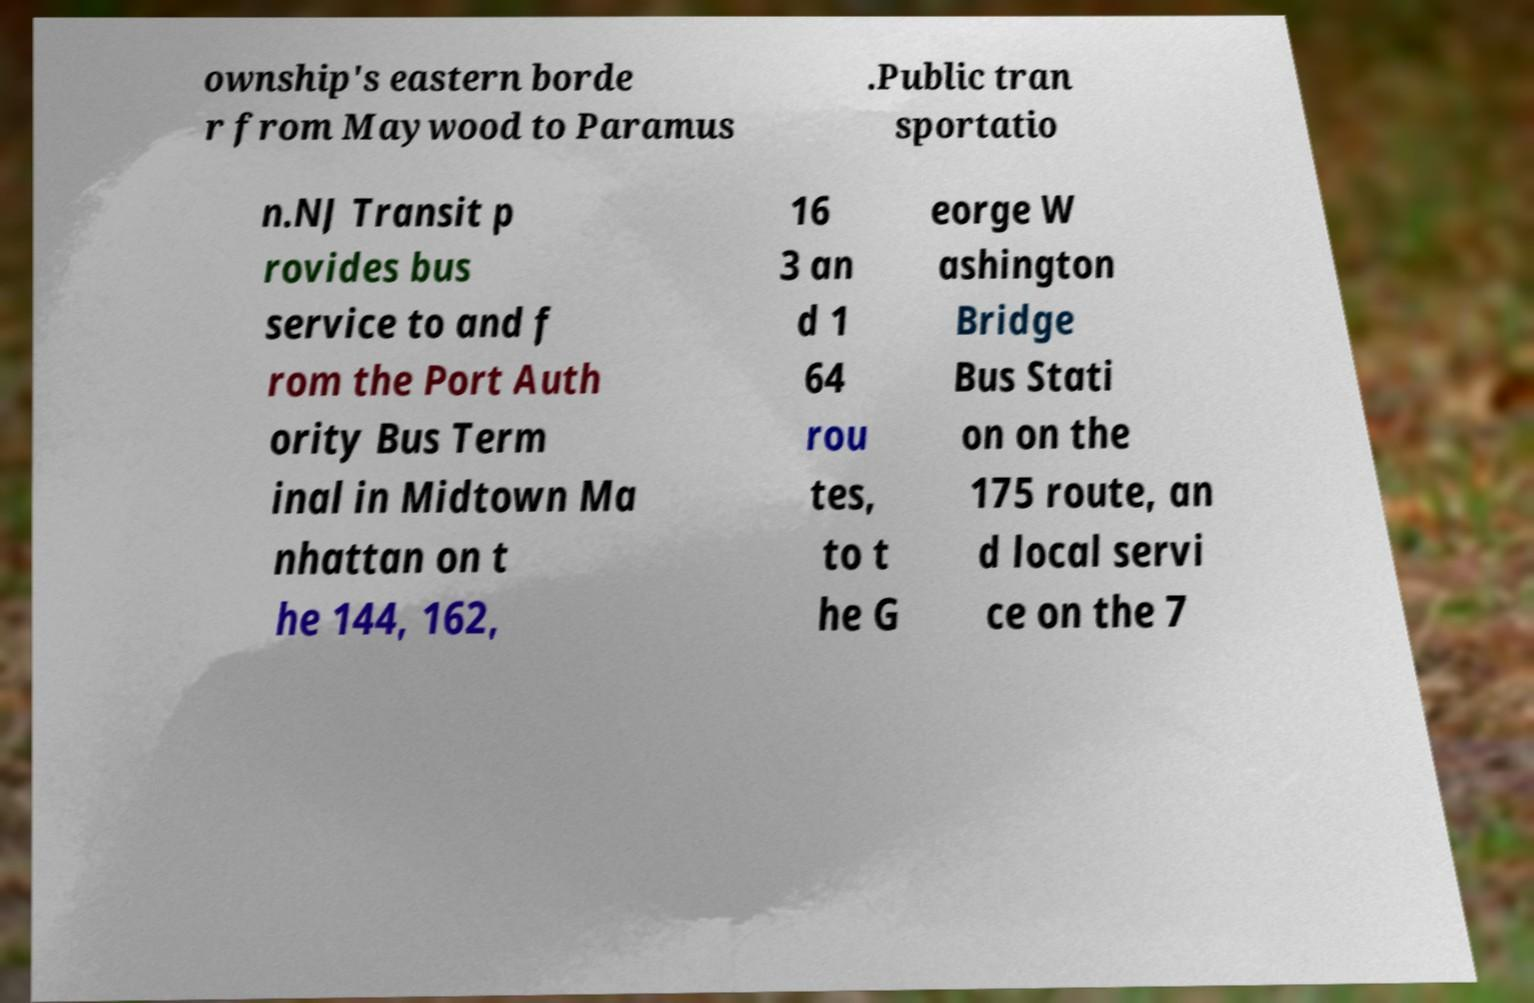I need the written content from this picture converted into text. Can you do that? ownship's eastern borde r from Maywood to Paramus .Public tran sportatio n.NJ Transit p rovides bus service to and f rom the Port Auth ority Bus Term inal in Midtown Ma nhattan on t he 144, 162, 16 3 an d 1 64 rou tes, to t he G eorge W ashington Bridge Bus Stati on on the 175 route, an d local servi ce on the 7 